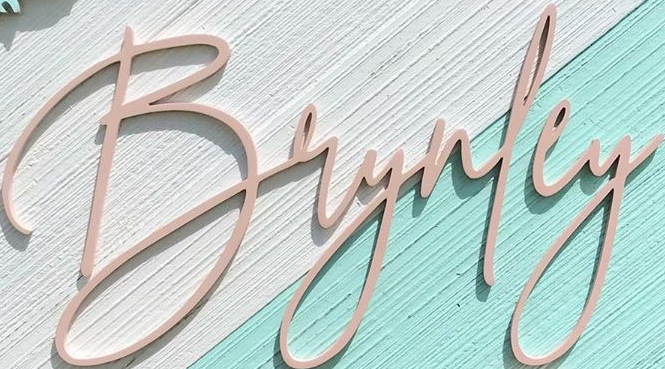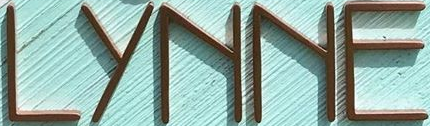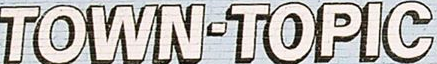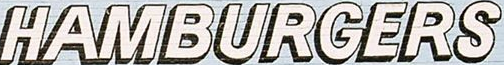Identify the words shown in these images in order, separated by a semicolon. Brynley; LYNNE; TOWN-TOPIC; HAMBURGERS 